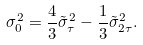Convert formula to latex. <formula><loc_0><loc_0><loc_500><loc_500>\sigma _ { 0 } ^ { 2 } = \frac { 4 } { 3 } \tilde { \sigma } ^ { 2 } _ { \tau } - \frac { 1 } { 3 } \tilde { \sigma } ^ { 2 } _ { 2 \tau } .</formula> 